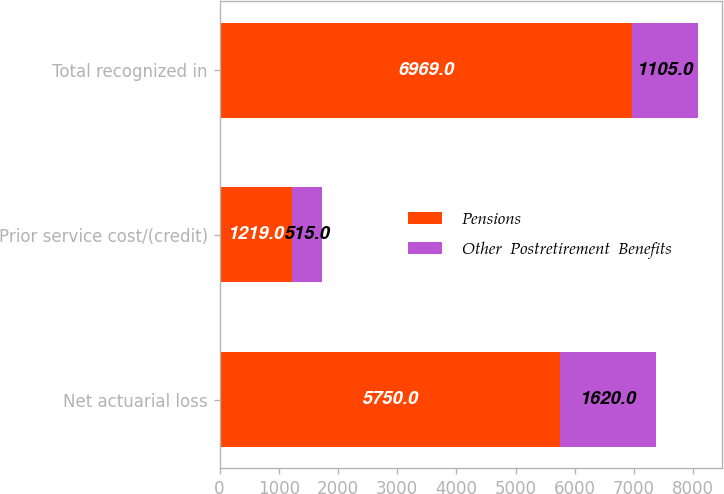Convert chart to OTSL. <chart><loc_0><loc_0><loc_500><loc_500><stacked_bar_chart><ecel><fcel>Net actuarial loss<fcel>Prior service cost/(credit)<fcel>Total recognized in<nl><fcel>Pensions<fcel>5750<fcel>1219<fcel>6969<nl><fcel>Other  Postretirement  Benefits<fcel>1620<fcel>515<fcel>1105<nl></chart> 